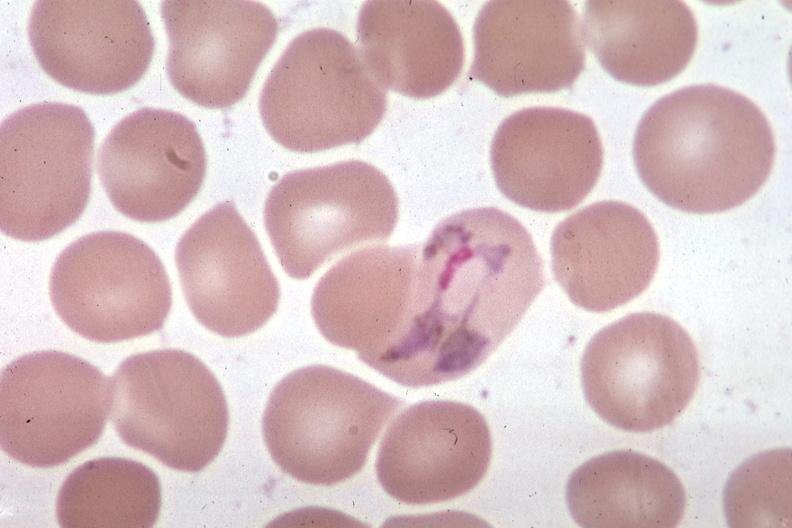s hematologic present?
Answer the question using a single word or phrase. Yes 